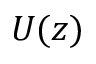Convert formula to latex. <formula><loc_0><loc_0><loc_500><loc_500>U ( z )</formula> 